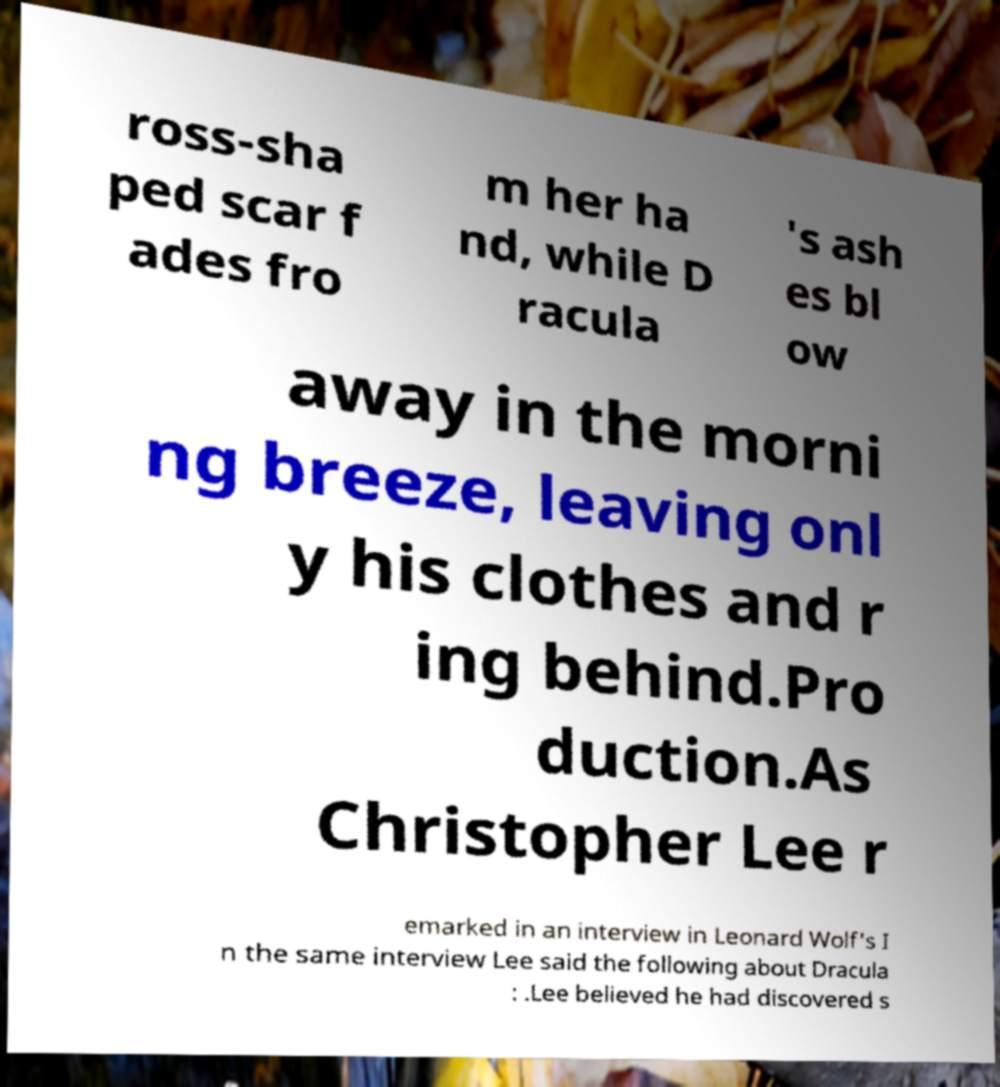There's text embedded in this image that I need extracted. Can you transcribe it verbatim? ross-sha ped scar f ades fro m her ha nd, while D racula 's ash es bl ow away in the morni ng breeze, leaving onl y his clothes and r ing behind.Pro duction.As Christopher Lee r emarked in an interview in Leonard Wolf's I n the same interview Lee said the following about Dracula : .Lee believed he had discovered s 